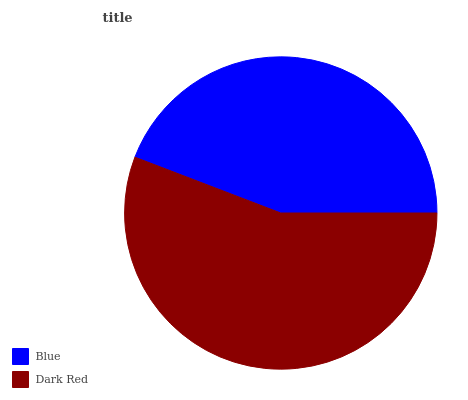Is Blue the minimum?
Answer yes or no. Yes. Is Dark Red the maximum?
Answer yes or no. Yes. Is Dark Red the minimum?
Answer yes or no. No. Is Dark Red greater than Blue?
Answer yes or no. Yes. Is Blue less than Dark Red?
Answer yes or no. Yes. Is Blue greater than Dark Red?
Answer yes or no. No. Is Dark Red less than Blue?
Answer yes or no. No. Is Dark Red the high median?
Answer yes or no. Yes. Is Blue the low median?
Answer yes or no. Yes. Is Blue the high median?
Answer yes or no. No. Is Dark Red the low median?
Answer yes or no. No. 